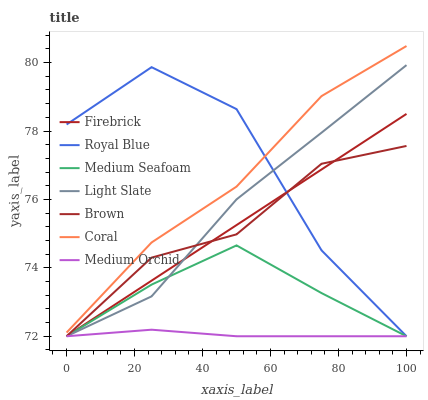Does Medium Orchid have the minimum area under the curve?
Answer yes or no. Yes. Does Royal Blue have the maximum area under the curve?
Answer yes or no. Yes. Does Brown have the minimum area under the curve?
Answer yes or no. No. Does Brown have the maximum area under the curve?
Answer yes or no. No. Is Firebrick the smoothest?
Answer yes or no. Yes. Is Royal Blue the roughest?
Answer yes or no. Yes. Is Brown the smoothest?
Answer yes or no. No. Is Brown the roughest?
Answer yes or no. No. Does Brown have the lowest value?
Answer yes or no. Yes. Does Coral have the highest value?
Answer yes or no. Yes. Does Brown have the highest value?
Answer yes or no. No. Is Firebrick less than Coral?
Answer yes or no. Yes. Is Coral greater than Brown?
Answer yes or no. Yes. Does Light Slate intersect Brown?
Answer yes or no. Yes. Is Light Slate less than Brown?
Answer yes or no. No. Is Light Slate greater than Brown?
Answer yes or no. No. Does Firebrick intersect Coral?
Answer yes or no. No. 